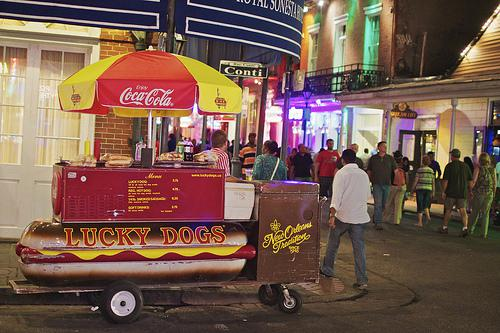Question: where are the people walking?
Choices:
A. Sidewalk.
B. Beach.
C. Street.
D. Field.
Answer with the letter. Answer: C Question: where are the hot dogs being sold from?
Choices:
A. Concession stand.
B. Grocery store.
C. Gas station.
D. Food cart.
Answer with the letter. Answer: D Question: what is the name of the food cart?
Choices:
A. Hank's Dogs.
B. Red Hots.
C. Lucky Dogs.
D. Doug's Hot Dogs.
Answer with the letter. Answer: C Question: when is the photo taken?
Choices:
A. Morning.
B. Night.
C. Noon.
D. Dusk.
Answer with the letter. Answer: B Question: what brand of soda is advertised on the food carts umbrella?
Choices:
A. Pepsi.
B. RC Cola.
C. Jones Soda.
D. Coca Cola.
Answer with the letter. Answer: D 